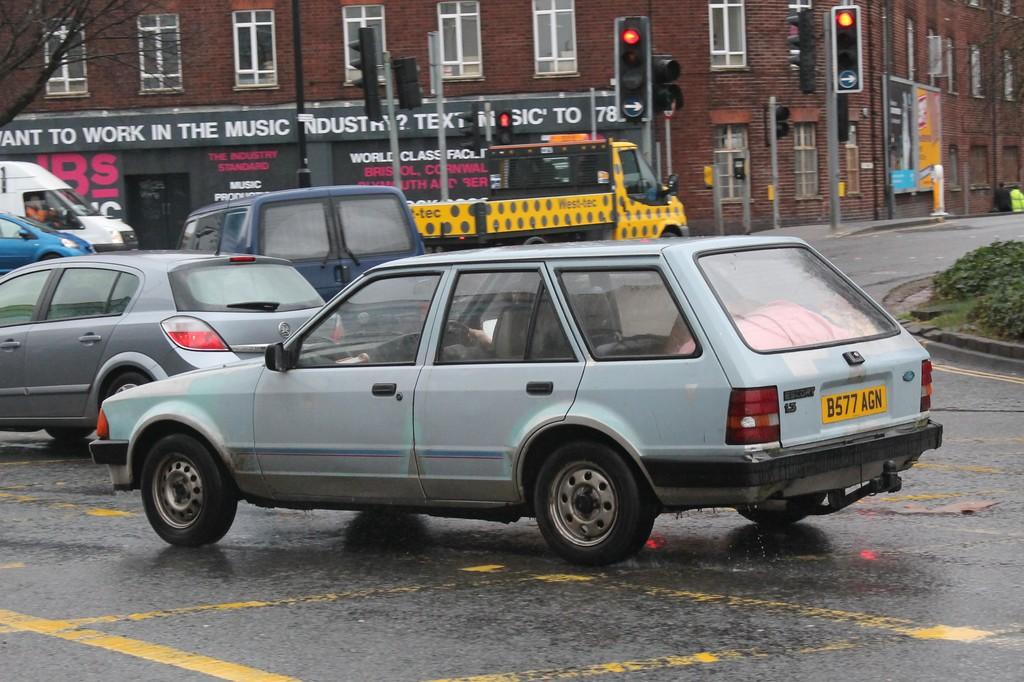<image>
Present a compact description of the photo's key features. A compact light colored four door Ford Escort with a 1.3 liter engine. 